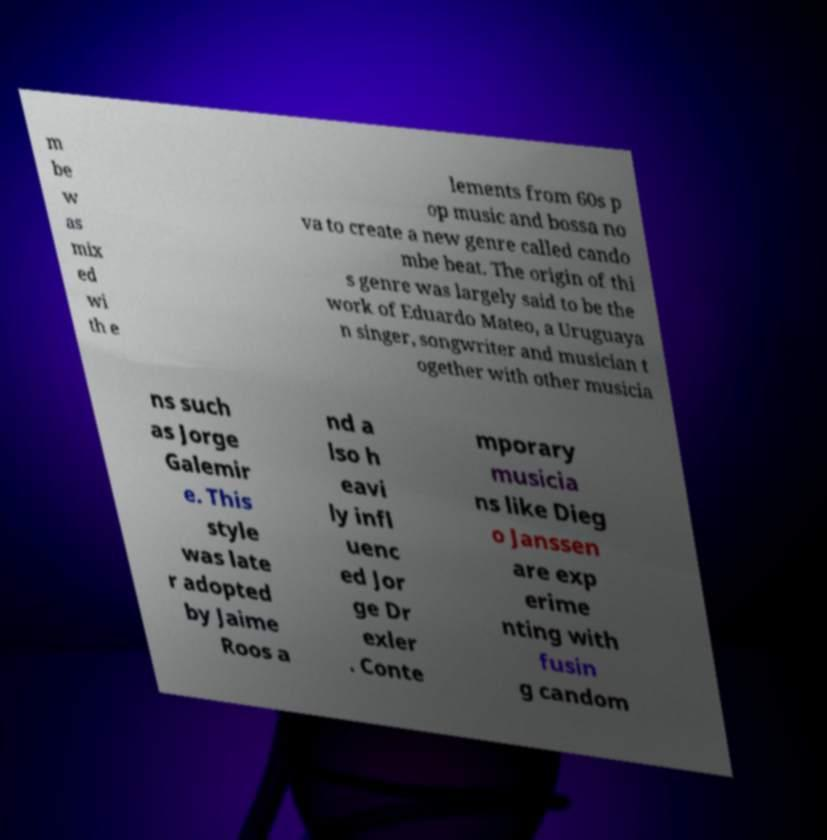Please identify and transcribe the text found in this image. m be w as mix ed wi th e lements from 60s p op music and bossa no va to create a new genre called cando mbe beat. The origin of thi s genre was largely said to be the work of Eduardo Mateo, a Uruguaya n singer, songwriter and musician t ogether with other musicia ns such as Jorge Galemir e. This style was late r adopted by Jaime Roos a nd a lso h eavi ly infl uenc ed Jor ge Dr exler . Conte mporary musicia ns like Dieg o Janssen are exp erime nting with fusin g candom 